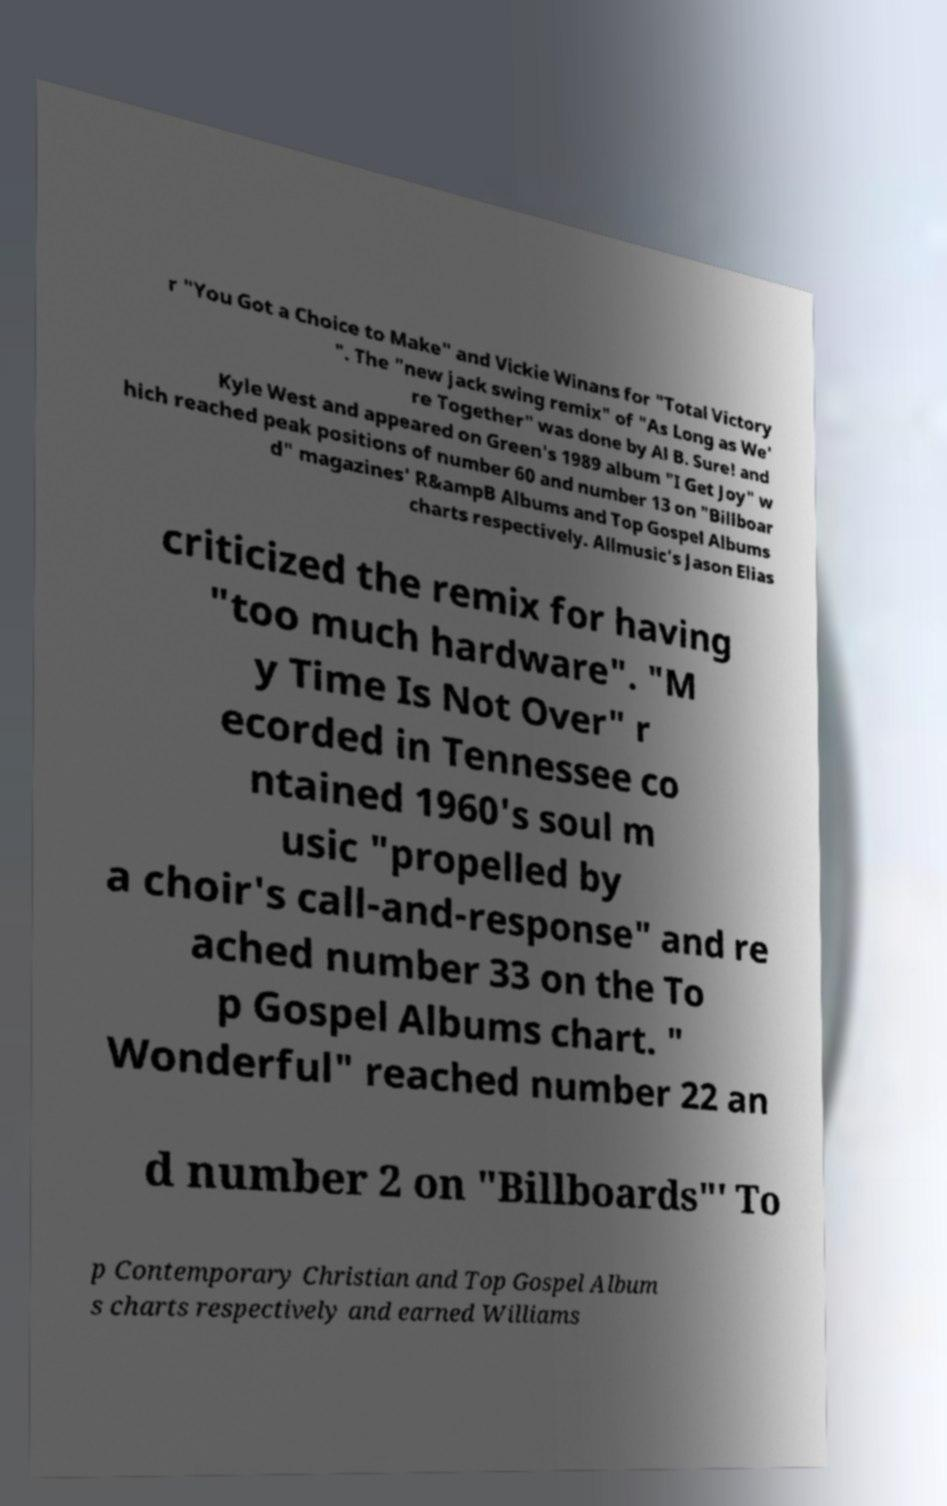Please read and relay the text visible in this image. What does it say? r "You Got a Choice to Make" and Vickie Winans for "Total Victory ". The "new jack swing remix" of "As Long as We' re Together" was done by Al B. Sure! and Kyle West and appeared on Green's 1989 album "I Get Joy" w hich reached peak positions of number 60 and number 13 on "Billboar d" magazines' R&ampB Albums and Top Gospel Albums charts respectively. Allmusic's Jason Elias criticized the remix for having "too much hardware". "M y Time Is Not Over" r ecorded in Tennessee co ntained 1960's soul m usic "propelled by a choir's call-and-response" and re ached number 33 on the To p Gospel Albums chart. " Wonderful" reached number 22 an d number 2 on "Billboards"' To p Contemporary Christian and Top Gospel Album s charts respectively and earned Williams 